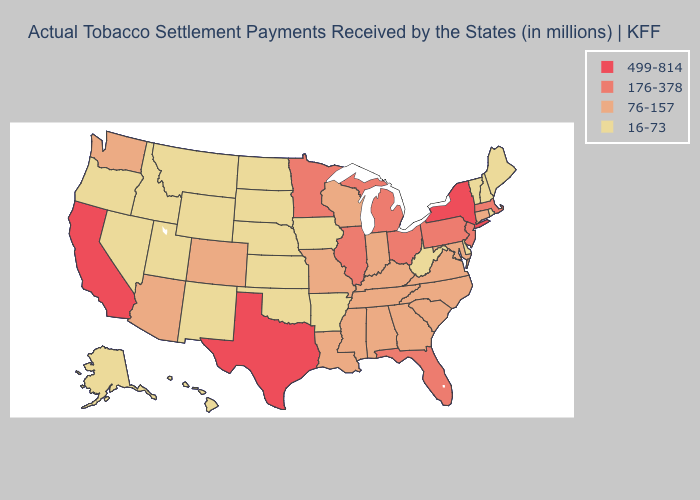Among the states that border Indiana , does Illinois have the lowest value?
Concise answer only. No. How many symbols are there in the legend?
Short answer required. 4. Does the map have missing data?
Keep it brief. No. Among the states that border New Jersey , which have the highest value?
Be succinct. New York. Does the map have missing data?
Be succinct. No. Does the map have missing data?
Quick response, please. No. Name the states that have a value in the range 16-73?
Give a very brief answer. Alaska, Arkansas, Delaware, Hawaii, Idaho, Iowa, Kansas, Maine, Montana, Nebraska, Nevada, New Hampshire, New Mexico, North Dakota, Oklahoma, Oregon, Rhode Island, South Dakota, Utah, Vermont, West Virginia, Wyoming. What is the value of Hawaii?
Keep it brief. 16-73. Name the states that have a value in the range 499-814?
Short answer required. California, New York, Texas. Name the states that have a value in the range 16-73?
Write a very short answer. Alaska, Arkansas, Delaware, Hawaii, Idaho, Iowa, Kansas, Maine, Montana, Nebraska, Nevada, New Hampshire, New Mexico, North Dakota, Oklahoma, Oregon, Rhode Island, South Dakota, Utah, Vermont, West Virginia, Wyoming. Name the states that have a value in the range 76-157?
Answer briefly. Alabama, Arizona, Colorado, Connecticut, Georgia, Indiana, Kentucky, Louisiana, Maryland, Mississippi, Missouri, North Carolina, South Carolina, Tennessee, Virginia, Washington, Wisconsin. Name the states that have a value in the range 499-814?
Quick response, please. California, New York, Texas. Which states have the lowest value in the MidWest?
Short answer required. Iowa, Kansas, Nebraska, North Dakota, South Dakota. What is the lowest value in the Northeast?
Keep it brief. 16-73. 